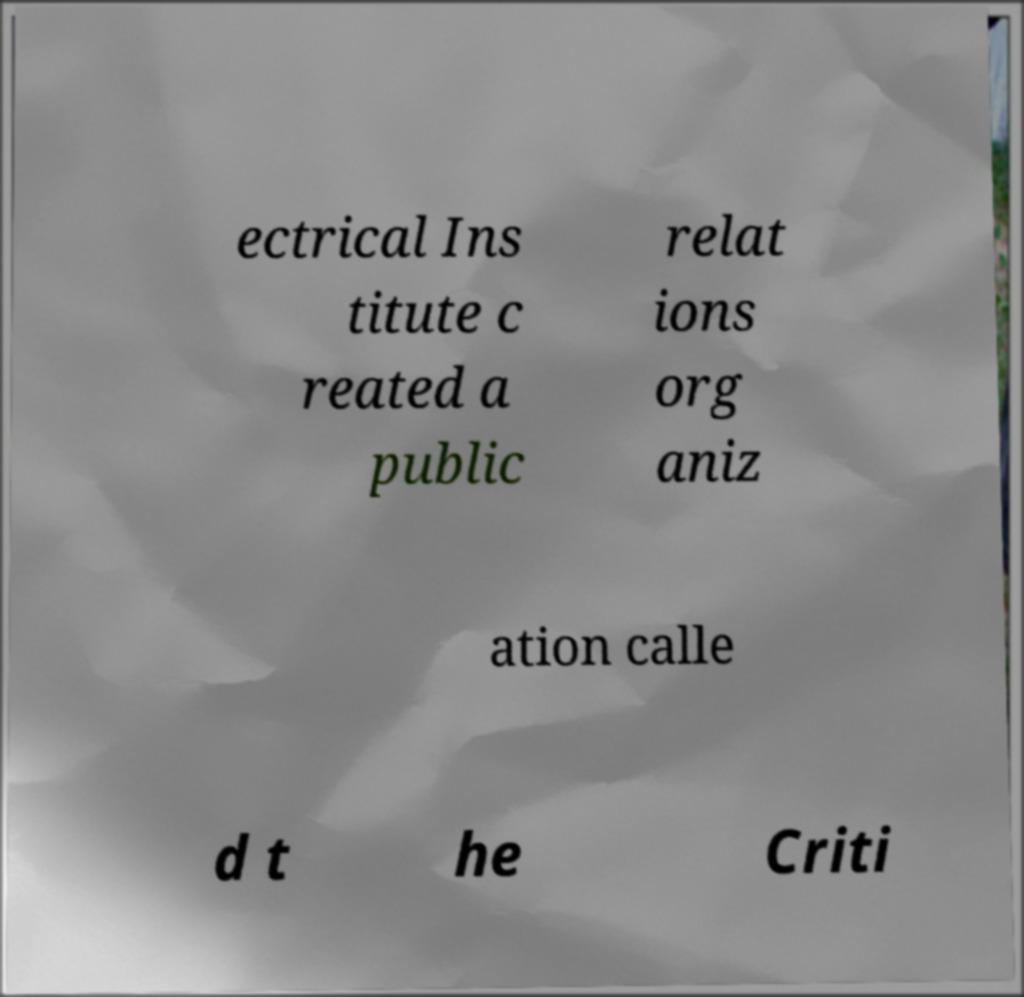For documentation purposes, I need the text within this image transcribed. Could you provide that? ectrical Ins titute c reated a public relat ions org aniz ation calle d t he Criti 